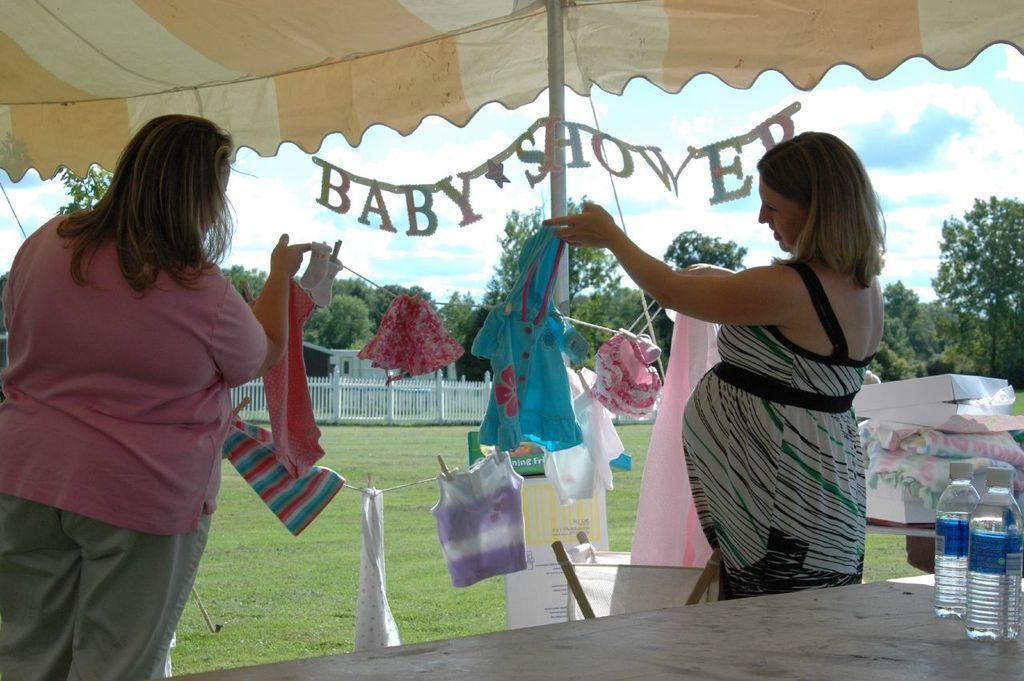Describe this image in one or two sentences. This picture is taken under a tent. There are two women in the picture. Towards the left there is a women wearing a pink t shirt and cream trousers and holding a socks. Towards the right there is another woman, she is wearing a white dress and holding a shirt. Between them there is a rope and some clothes hanged to it. In the right bottom there is a table and there are bottles on it. In the background there are trees, a fence and a blue sky. 